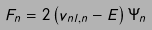<formula> <loc_0><loc_0><loc_500><loc_500>F _ { n } = 2 \left ( v _ { n l , n } - E \right ) \Psi _ { n }</formula> 